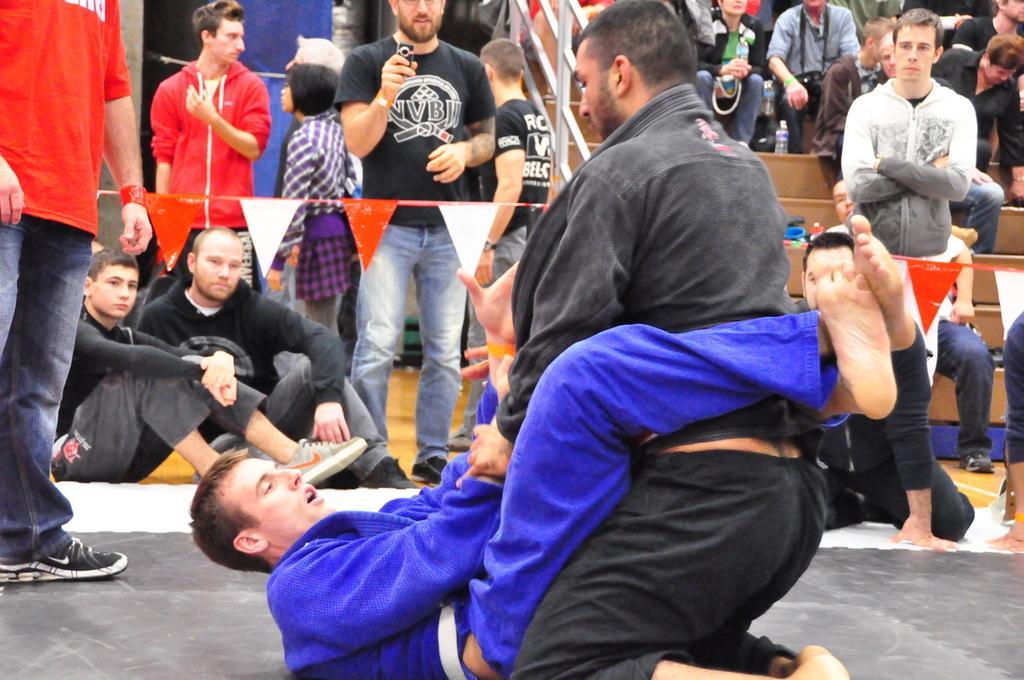What are the two persons in the middle of the image doing? The two persons in the middle of the image are wrestling. What are the people on the left side of the image doing? The people on the left side of the image are standing and watching the wrestling. What are the people on the right side of the image doing? The people on the right side of the image are sitting. What type of quilt is being used as a seat by the people on the right side of the image? There is no quilt present in the image, and no one is using a quilt as a seat. 